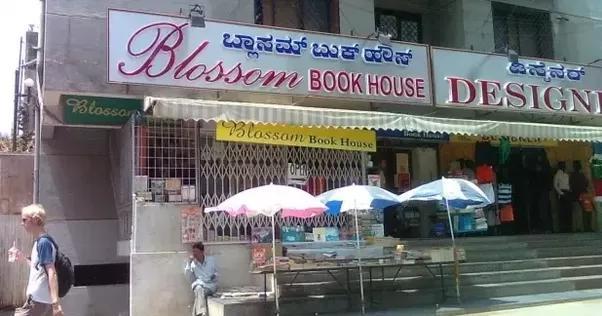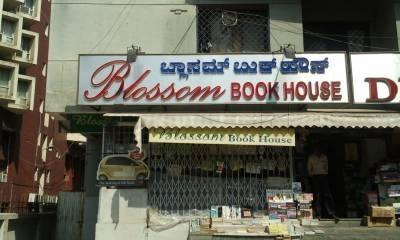The first image is the image on the left, the second image is the image on the right. Examine the images to the left and right. Is the description "People stand in the entrance of the store in the image on the left." accurate? Answer yes or no. Yes. The first image is the image on the left, the second image is the image on the right. Given the left and right images, does the statement "Left images shows a shop with a lattice-like structure in front, behind a banner sign." hold true? Answer yes or no. Yes. 